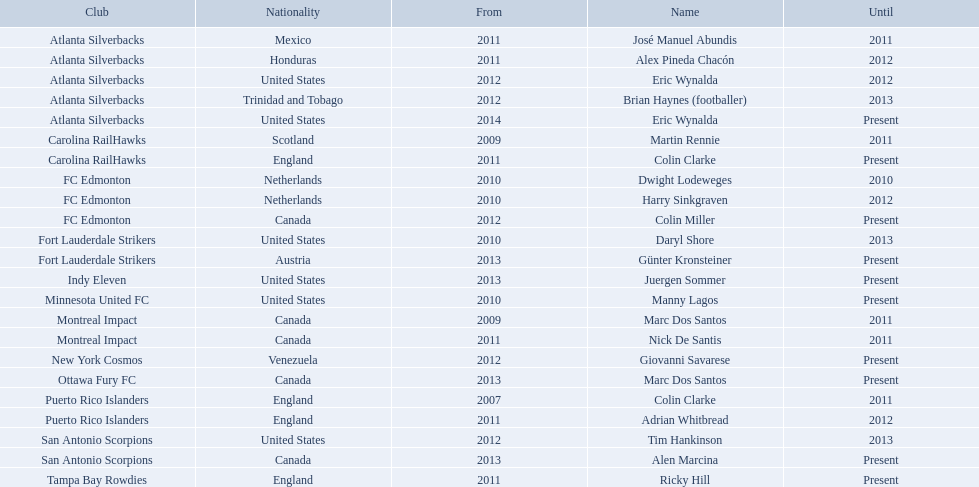What year did marc dos santos start as coach? 2009. Besides marc dos santos, what other coach started in 2009? Martin Rennie. What year did marc dos santos start as coach? 2009. Which other starting years correspond with this year? 2009. Who was the other coach with this starting year Martin Rennie. 